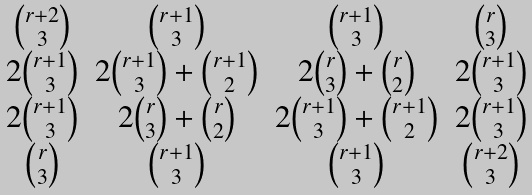Convert formula to latex. <formula><loc_0><loc_0><loc_500><loc_500>\begin{matrix} \binom { r + 2 } { 3 } & \binom { r + 1 } { 3 } & \binom { r + 1 } { 3 } & \binom { r } { 3 } \\ 2 \binom { r + 1 } { 3 } & 2 \binom { r + 1 } { 3 } + \binom { r + 1 } { 2 } & 2 \binom { r } { 3 } + \binom { r } { 2 } & 2 \binom { r + 1 } { 3 } \\ 2 \binom { r + 1 } { 3 } & 2 \binom { r } { 3 } + \binom { r } { 2 } & 2 \binom { r + 1 } { 3 } + \binom { r + 1 } { 2 } & 2 \binom { r + 1 } { 3 } \\ \binom { r } { 3 } & \binom { r + 1 } { 3 } & \binom { r + 1 } { 3 } & \binom { r + 2 } { 3 } \end{matrix}</formula> 